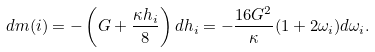<formula> <loc_0><loc_0><loc_500><loc_500>d m ( i ) = - \left ( G + \frac { \kappa h _ { i } } { 8 } \right ) d h _ { i } = - \frac { 1 6 G ^ { 2 } } { \kappa } ( 1 + 2 \omega _ { i } ) d \omega _ { i } .</formula> 